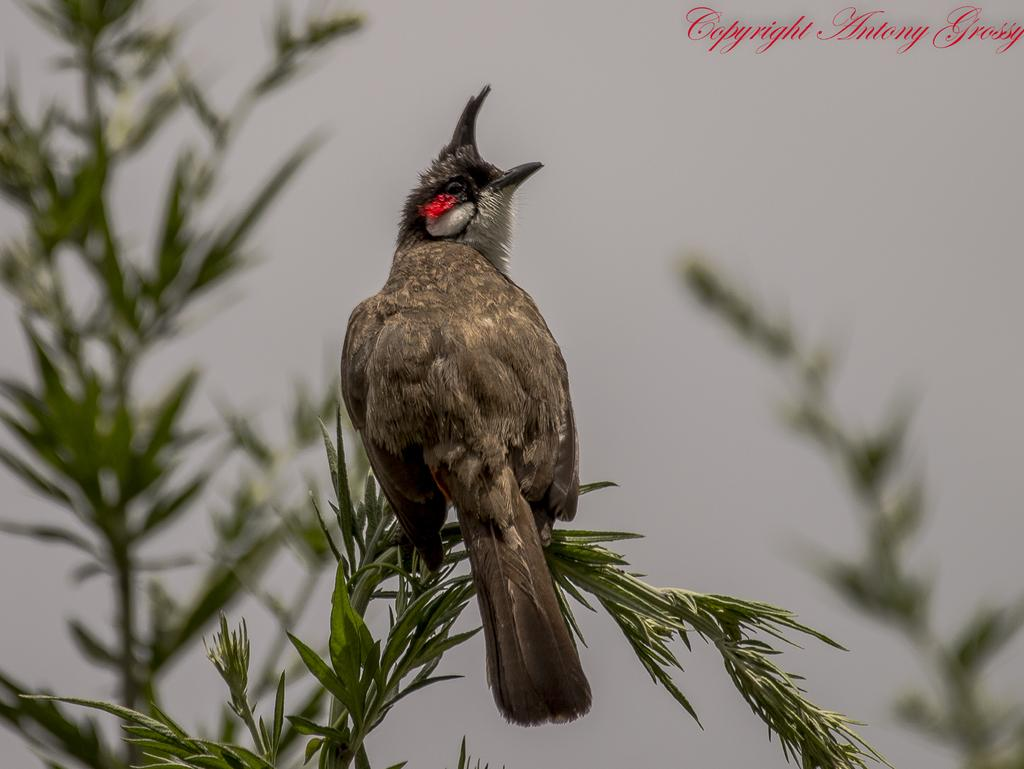What type of animal can be seen in the image? There is a bird in the image. Where is the bird located? The bird is on a stem with leaves. What can be observed about the background of the image? The background is blurred. What other natural elements are visible in the image? There are branches visible in the image. Is there any text present in the image? Yes, there is text written in the right top corner of the image. How many cats are playing with the servant in the image? There are no cats or servants present in the image; it features a bird on a stem with leaves. 